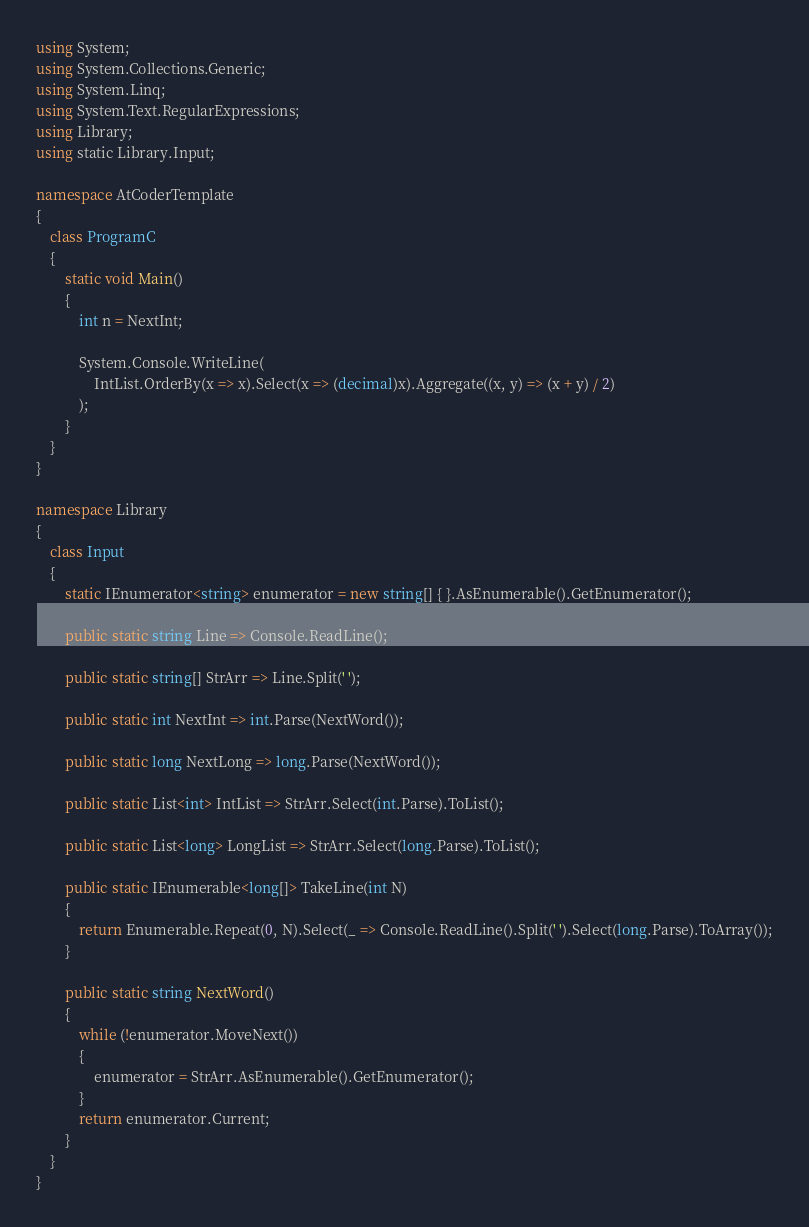Convert code to text. <code><loc_0><loc_0><loc_500><loc_500><_C#_>using System;
using System.Collections.Generic;
using System.Linq;
using System.Text.RegularExpressions;
using Library;
using static Library.Input;

namespace AtCoderTemplate
{
    class ProgramC
    {
        static void Main()
        {
            int n = NextInt;

            System.Console.WriteLine(
                IntList.OrderBy(x => x).Select(x => (decimal)x).Aggregate((x, y) => (x + y) / 2)
            );
        }
    }
}

namespace Library
{
    class Input
    {
        static IEnumerator<string> enumerator = new string[] { }.AsEnumerable().GetEnumerator();

        public static string Line => Console.ReadLine();

        public static string[] StrArr => Line.Split(' ');

        public static int NextInt => int.Parse(NextWord());

        public static long NextLong => long.Parse(NextWord());

        public static List<int> IntList => StrArr.Select(int.Parse).ToList();

        public static List<long> LongList => StrArr.Select(long.Parse).ToList();

        public static IEnumerable<long[]> TakeLine(int N)
        {
            return Enumerable.Repeat(0, N).Select(_ => Console.ReadLine().Split(' ').Select(long.Parse).ToArray());
        }

        public static string NextWord()
        {
            while (!enumerator.MoveNext())
            {
                enumerator = StrArr.AsEnumerable().GetEnumerator();
            }
            return enumerator.Current;
        }
    }
}
</code> 